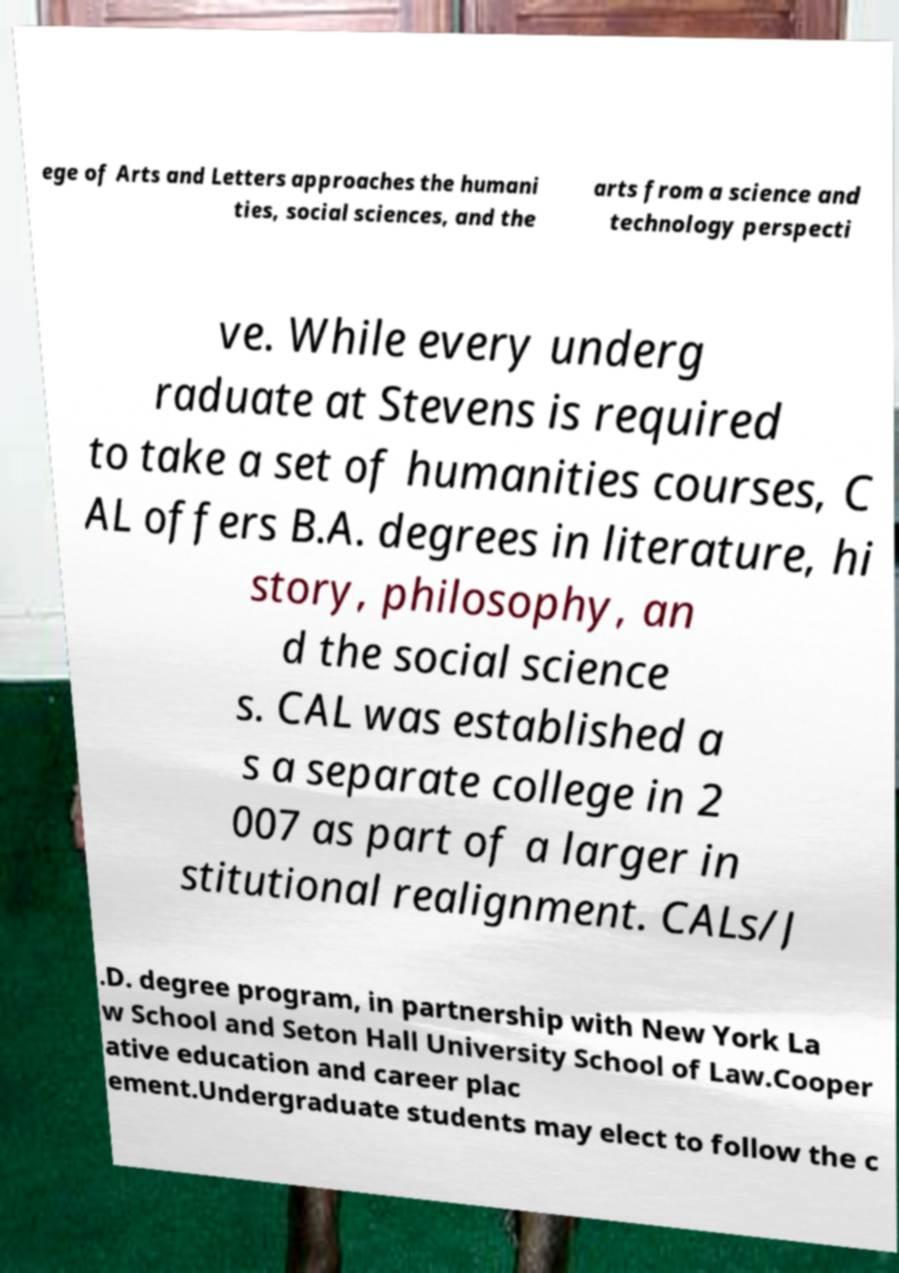There's text embedded in this image that I need extracted. Can you transcribe it verbatim? ege of Arts and Letters approaches the humani ties, social sciences, and the arts from a science and technology perspecti ve. While every underg raduate at Stevens is required to take a set of humanities courses, C AL offers B.A. degrees in literature, hi story, philosophy, an d the social science s. CAL was established a s a separate college in 2 007 as part of a larger in stitutional realignment. CALs/J .D. degree program, in partnership with New York La w School and Seton Hall University School of Law.Cooper ative education and career plac ement.Undergraduate students may elect to follow the c 